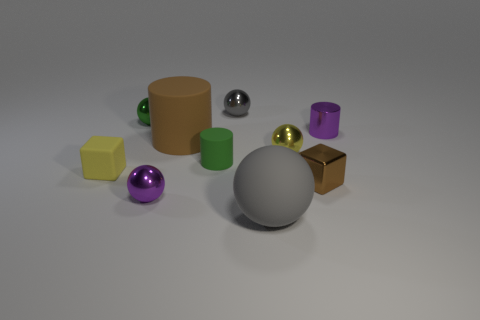Subtract 1 balls. How many balls are left? 4 Subtract all yellow spheres. How many spheres are left? 4 Subtract all tiny yellow shiny spheres. How many spheres are left? 4 Subtract all blue spheres. Subtract all red blocks. How many spheres are left? 5 Subtract all cylinders. How many objects are left? 7 Subtract all big brown shiny objects. Subtract all tiny brown objects. How many objects are left? 9 Add 1 small green balls. How many small green balls are left? 2 Add 4 brown rubber balls. How many brown rubber balls exist? 4 Subtract 1 brown cubes. How many objects are left? 9 